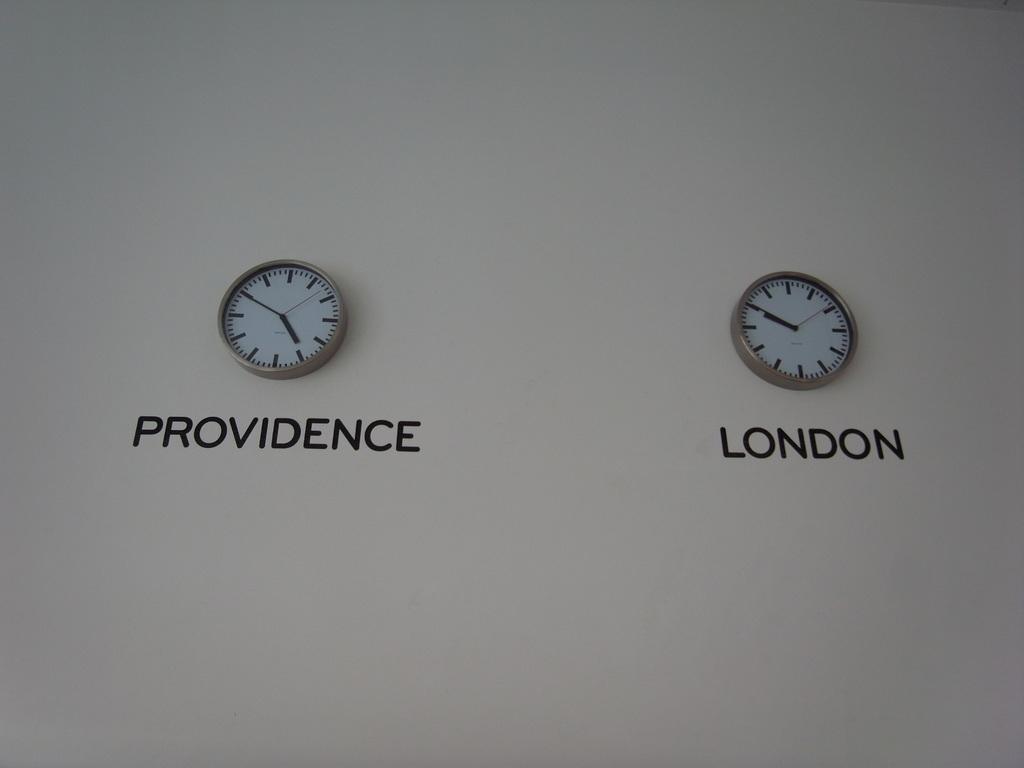What´s city does the clock on the left  tell the time of?
Your answer should be very brief. Providence. 